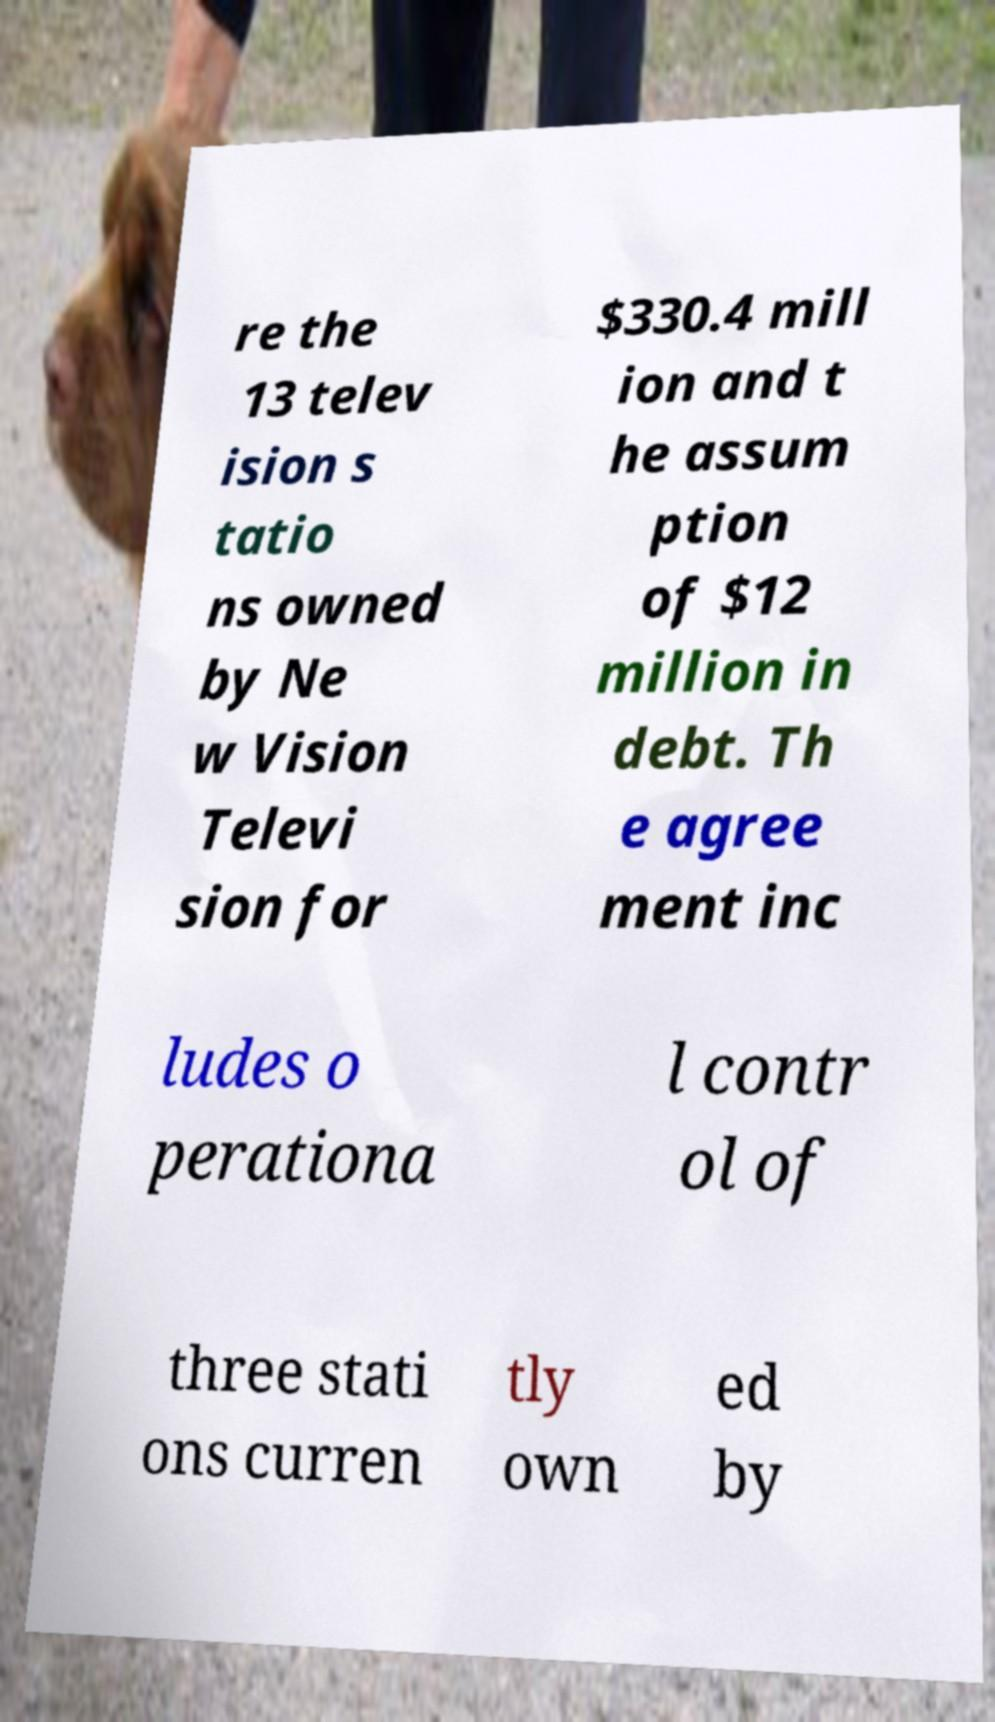Could you extract and type out the text from this image? re the 13 telev ision s tatio ns owned by Ne w Vision Televi sion for $330.4 mill ion and t he assum ption of $12 million in debt. Th e agree ment inc ludes o perationa l contr ol of three stati ons curren tly own ed by 